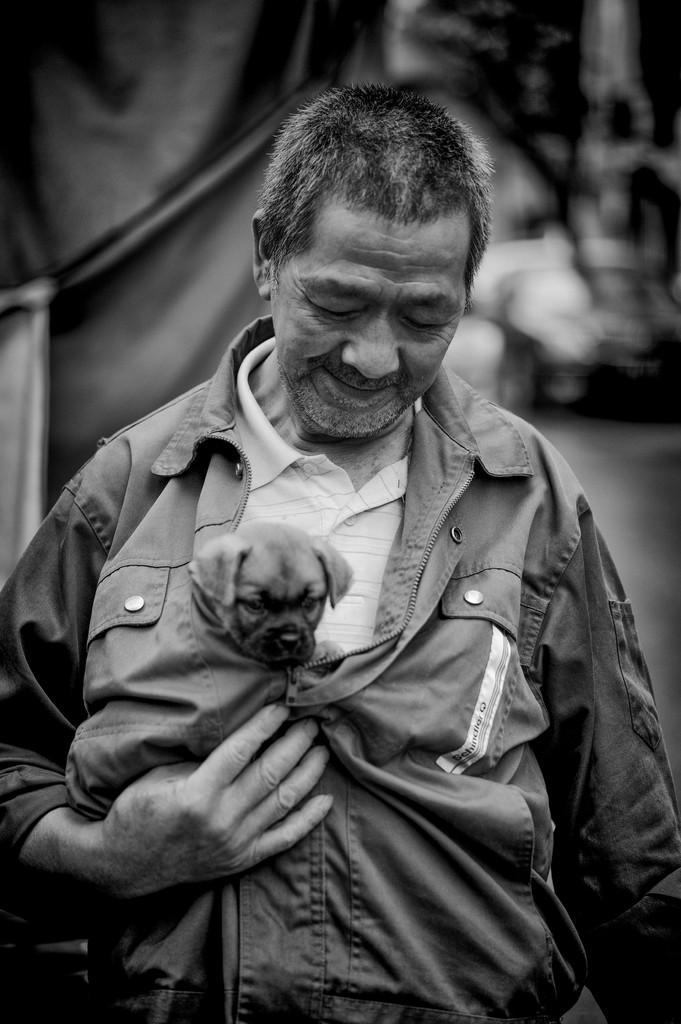In one or two sentences, can you explain what this image depicts? In the center we can see one person standing and he is smiling and he is holding dog. In the background there is a sheet. 